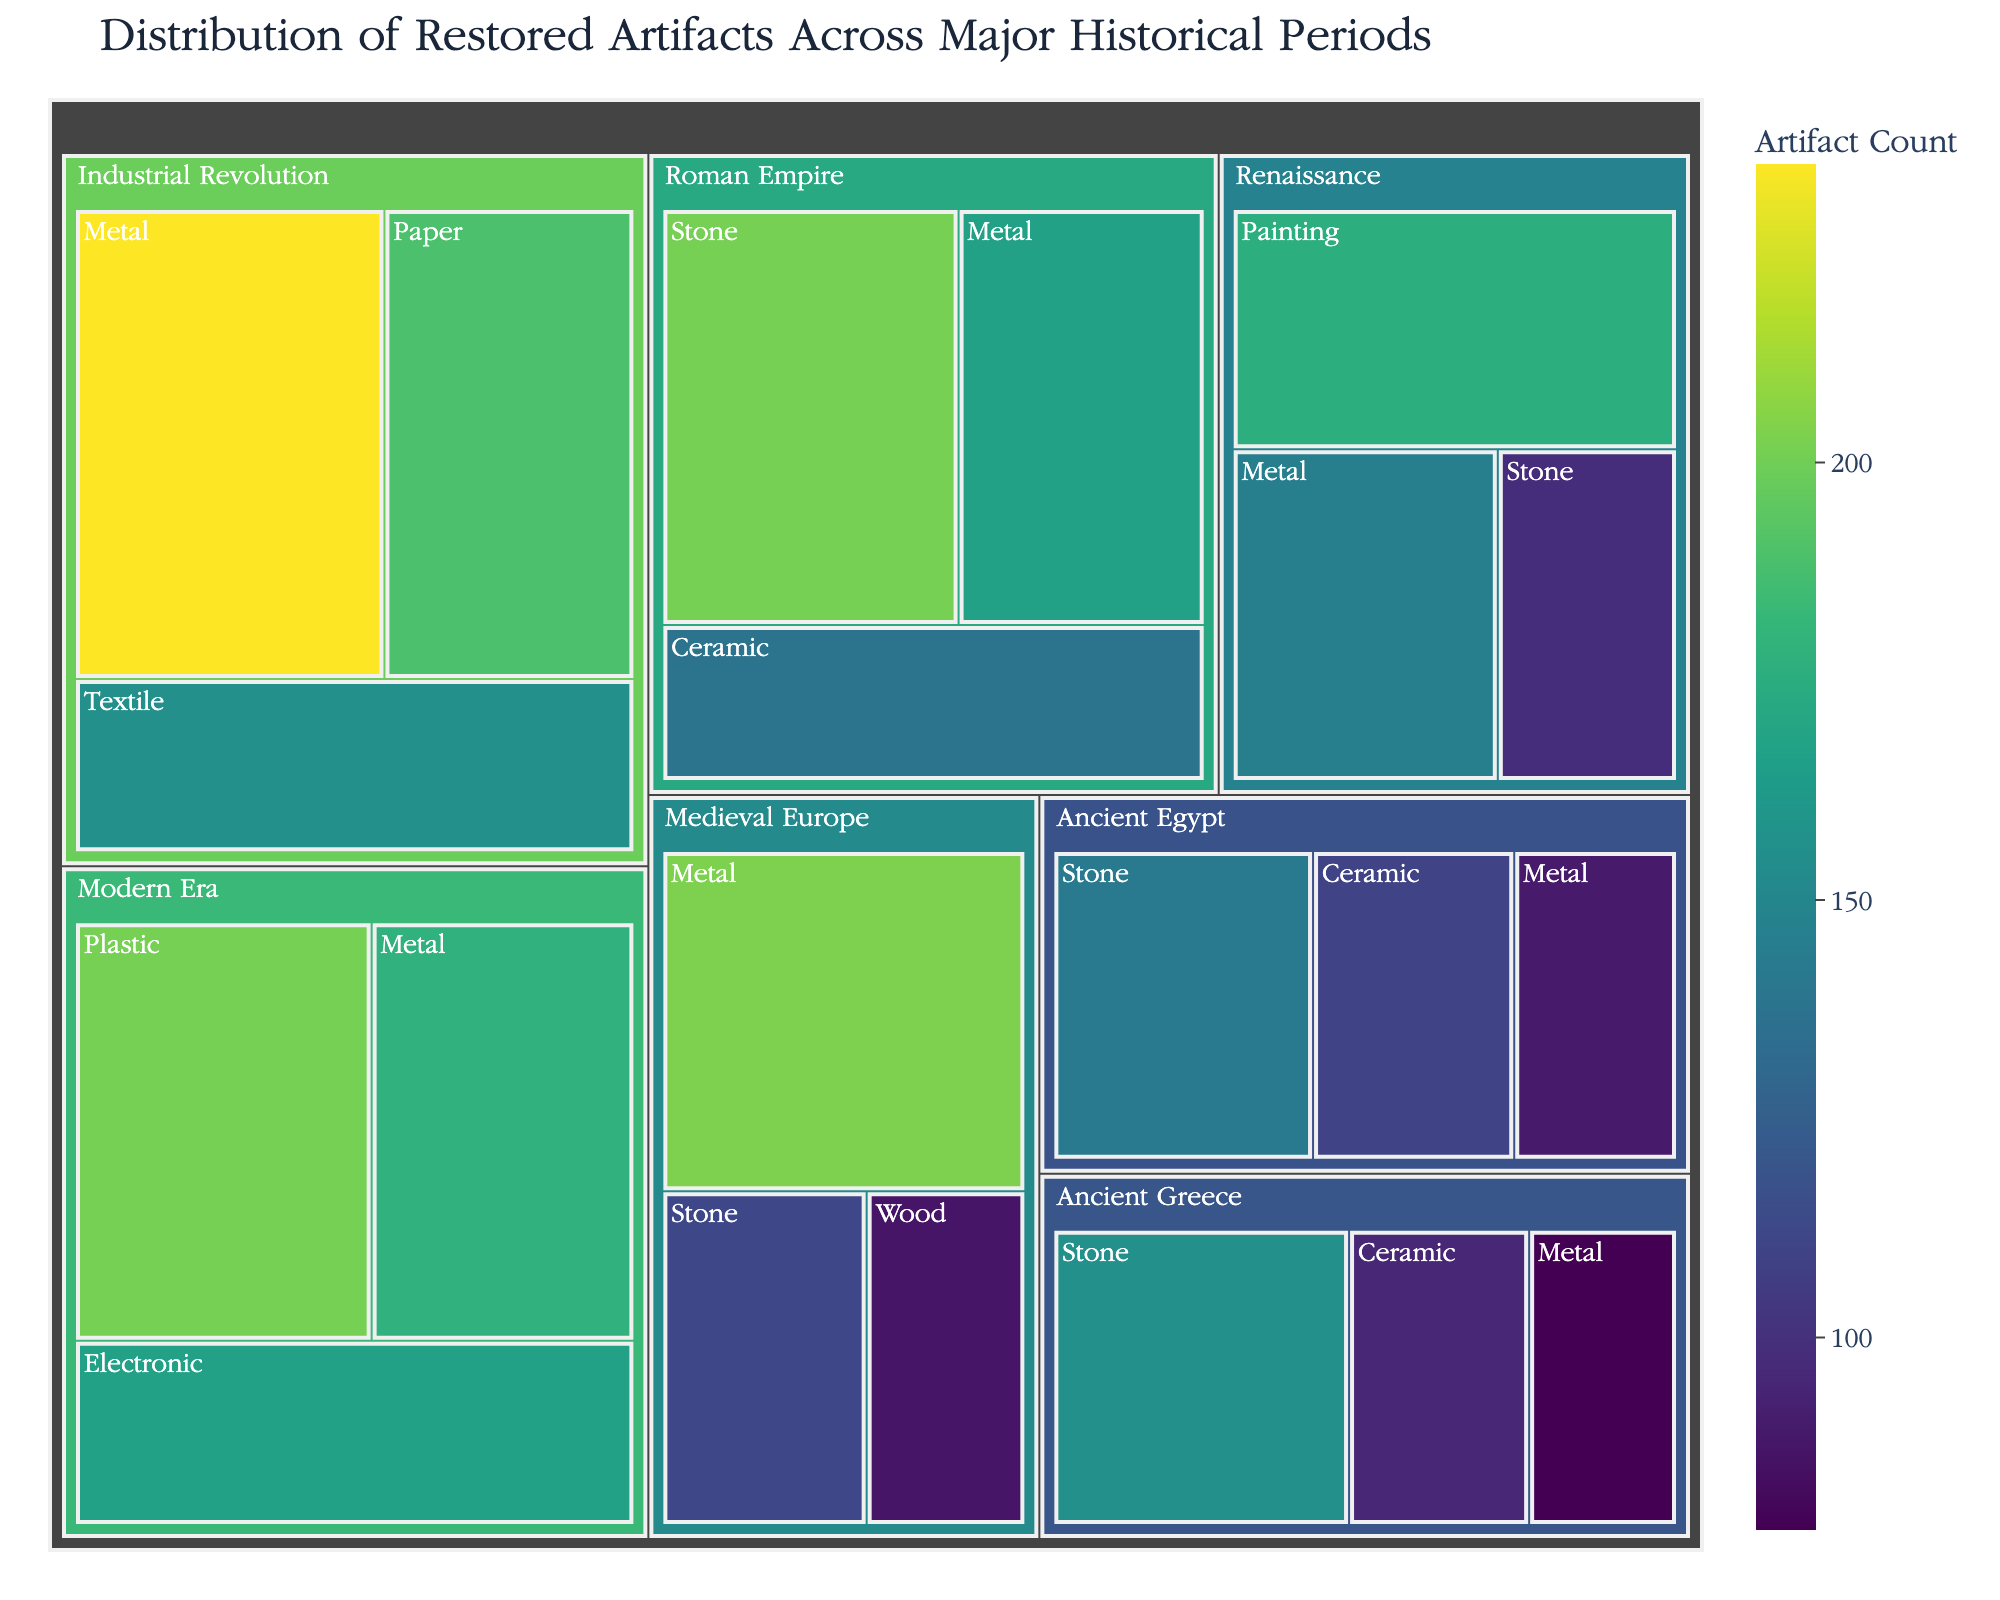What's the title of the Treemap? The title of the Treemap is displayed prominently at the top of the chart. It provides a summary of the content represented in the Treemap. The title here indicates the nature of the data being visualized.
Answer: Distribution of Restored Artifacts Across Major Historical Periods Which historical period has the highest count of restored stone artifacts? Look for the section labeled "Stone" within each historical period and compare the values. The Roman Empire has the highest count of stone artifacts indicated by its color intensity and the numerical count displayed.
Answer: Roman Empire How many restored artifacts of metal are there in the Renaissance period? Navigate to the section labeled "Renaissance" and then find the division within it for "Metal". The count is displayed in this section.
Answer: 145 Compare the number of restored ceramic artifacts in Ancient Egypt and Ancient Greece. Which period has more? Locate the sections for "Ceramic" within "Ancient Egypt" and "Ancient Greece" respectively. Compare the counts provided in each division.
Answer: Ancient Egypt What is the total number of restored artifacts in the Industrial Revolution period? Sum the counts of all material types (Metal, Textile, Paper) within the Industrial Revolution section. The calculation is 234 (Metal) + 156 (Textile) + 189 (Paper) = 579.
Answer: 579 Do any periods have restored artifacts made of wood? If so, how many? Examine the Treemap for the presence of a section labeled "Wood" under any historical period. Medieval Europe has wood artifacts, and the count is displayed.
Answer: Yes, 87 Which period has the lowest count of restored artifacts across all material types, and what is that count? Sum the counts of artifacts within each historical period and compare. The Renaissance period has the lowest total count, which can be calculated by adding its artifact counts: 98 (Stone) + 145 (Metal) + 176 (Painting) = 419.
Answer: Renaissance, 419 Compare the counts of restored metal artifacts in the Roman Empire and Modern Era. Which one has more, and by how much? Locate the metal artifact counts for both periods. Roman Empire has 167, and Modern Era has 178. Subtract to find the difference: 178 - 167 = 11.
Answer: Modern Era, by 11 What is the most common material type for restored artifacts in the Modern Era? Among the categories of materials in the Modern Era section, compare the counts. Plastic has the highest count.
Answer: Plastic If you combine the counts of stone artifacts across all periods, what total do you get? Add the counts of stone artifacts in each period: 142 (Ancient Egypt) + 156 (Ancient Greece) + 201 (Roman Empire) + 112 (Medieval Europe) + 98 (Renaissance) = 709.
Answer: 709 